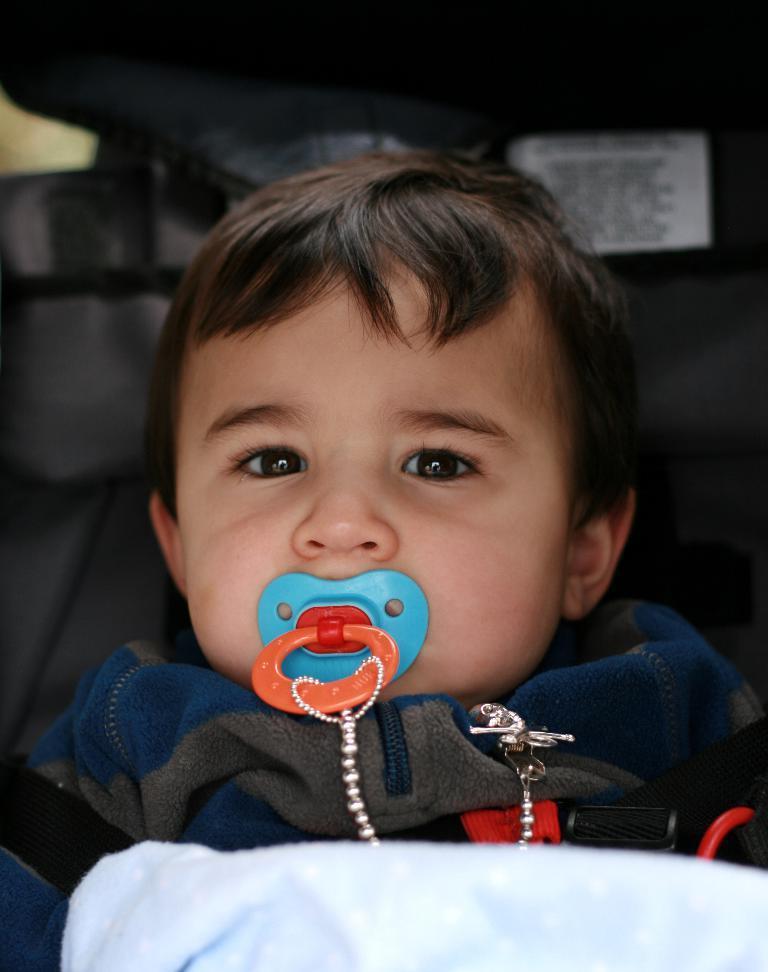How would you summarize this image in a sentence or two? In this image I can see a baby laying. The baby is wearing blue and gray color dress, I can also see an object which is in blue and red color in the babies mouth. 